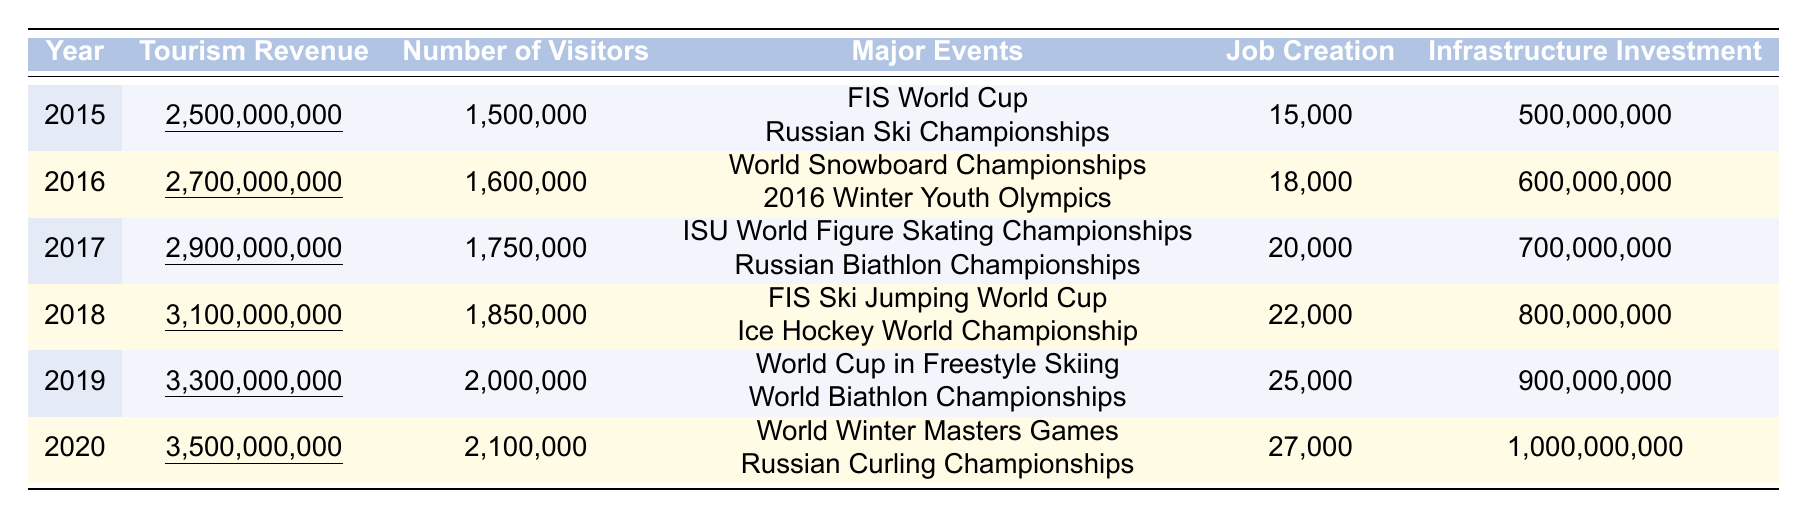What was the tourism revenue in 2018? The table shows that the tourism revenue for the year 2018 is underlined as 3,100,000,000.
Answer: 3,100,000,000 How many visitors came to Russia for winter sports in 2017? Referring to the table, the number of visitors for the year 2017 is 1,750,000.
Answer: 1,750,000 Which year had the highest job creation and how many jobs were created? Looking at the job creation column, 2020 has the highest number of jobs created at 27,000.
Answer: 27,000 What is the total infrastructure investment from 2015 to 2020? To find the total, add the infrastructure investments: 500,000,000 + 600,000,000 + 700,000,000 + 800,000,000 + 900,000,000 + 1,000,000,000 = 4,500,000,000.
Answer: 4,500,000,000 In which year did the number of visitors exceed 2 million? By checking the number of visitors, 2019 and 2020 exceed 2 million with 2,000,000 and 2,100,000 respectively.
Answer: 2019 and 2020 What was the average tourism revenue from 2015 to 2020? To calculate the average, sum up the tourism revenues: 2,500,000,000 + 2,700,000,000 + 2,900,000,000 + 3,100,000,000 + 3,300,000,000 + 3,500,000,000 = 18,000,000,000. Then divide by 6 (years): 18,000,000,000 / 6 = 3,000,000,000.
Answer: 3,000,000,000 Did the total number of visitors in 2019 increase compared to 2015? The number of visitors in 2019 is 2,000,000 while in 2015 it's 1,500,000. Since 2,000,000 is greater than 1,500,000, the number increased.
Answer: Yes What event was held in Russia in 2016? The major events listed for 2016 are the World Snowboard Championships and the 2016 Winter Youth Olympics.
Answer: World Snowboard Championships and 2016 Winter Youth Olympics Which year had the least infrastructure investment and what was the amount? By reviewing the infrastructure investment column, 2015 showed the least investment at 500,000,000.
Answer: 500,000,000 Calculate the difference in tourism revenue between 2016 and 2019. The tourism revenue in 2016 is 2,700,000,000, and in 2019 it is 3,300,000,000. The difference is 3,300,000,000 - 2,700,000,000 = 600,000,000.
Answer: 600,000,000 Which year had the highest tourism revenue and what was the revenue? Examining the tourism revenue, 2020 had the highest revenue, which is 3,500,000,000.
Answer: 3,500,000,000 